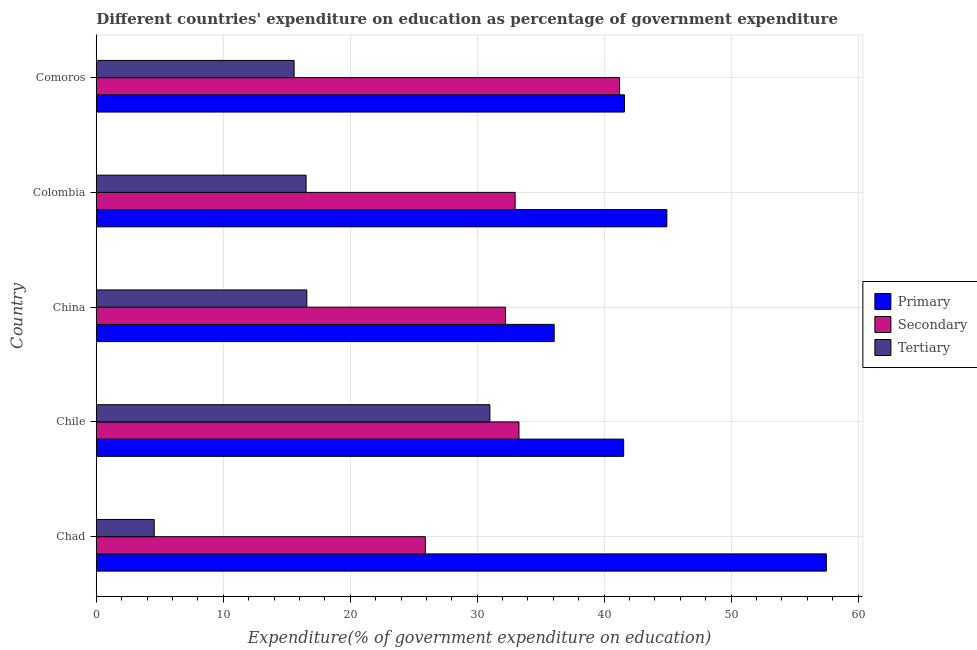How many bars are there on the 3rd tick from the top?
Your answer should be compact. 3. How many bars are there on the 4th tick from the bottom?
Offer a terse response. 3. What is the label of the 2nd group of bars from the top?
Your answer should be compact. Colombia. In how many cases, is the number of bars for a given country not equal to the number of legend labels?
Offer a very short reply. 0. What is the expenditure on secondary education in Comoros?
Keep it short and to the point. 41.21. Across all countries, what is the maximum expenditure on tertiary education?
Your response must be concise. 31. Across all countries, what is the minimum expenditure on secondary education?
Offer a terse response. 25.92. In which country was the expenditure on secondary education maximum?
Provide a succinct answer. Comoros. In which country was the expenditure on tertiary education minimum?
Provide a short and direct response. Chad. What is the total expenditure on tertiary education in the graph?
Your answer should be very brief. 84.25. What is the difference between the expenditure on secondary education in China and that in Comoros?
Provide a short and direct response. -8.98. What is the difference between the expenditure on secondary education in China and the expenditure on tertiary education in Chad?
Make the answer very short. 27.66. What is the average expenditure on primary education per country?
Provide a succinct answer. 44.33. What is the difference between the expenditure on secondary education and expenditure on tertiary education in Comoros?
Provide a short and direct response. 25.63. What is the ratio of the expenditure on primary education in China to that in Colombia?
Offer a terse response. 0.8. Is the difference between the expenditure on tertiary education in Chile and Comoros greater than the difference between the expenditure on primary education in Chile and Comoros?
Offer a very short reply. Yes. What is the difference between the highest and the second highest expenditure on primary education?
Give a very brief answer. 12.56. What is the difference between the highest and the lowest expenditure on primary education?
Make the answer very short. 21.44. Is the sum of the expenditure on tertiary education in China and Colombia greater than the maximum expenditure on primary education across all countries?
Your response must be concise. No. What does the 2nd bar from the top in Comoros represents?
Give a very brief answer. Secondary. What does the 1st bar from the bottom in Chile represents?
Your response must be concise. Primary. Is it the case that in every country, the sum of the expenditure on primary education and expenditure on secondary education is greater than the expenditure on tertiary education?
Keep it short and to the point. Yes. How many bars are there?
Your response must be concise. 15. Are all the bars in the graph horizontal?
Offer a very short reply. Yes. How many countries are there in the graph?
Give a very brief answer. 5. What is the difference between two consecutive major ticks on the X-axis?
Offer a terse response. 10. Are the values on the major ticks of X-axis written in scientific E-notation?
Make the answer very short. No. Where does the legend appear in the graph?
Your response must be concise. Center right. How many legend labels are there?
Make the answer very short. 3. How are the legend labels stacked?
Keep it short and to the point. Vertical. What is the title of the graph?
Give a very brief answer. Different countries' expenditure on education as percentage of government expenditure. What is the label or title of the X-axis?
Provide a succinct answer. Expenditure(% of government expenditure on education). What is the Expenditure(% of government expenditure on education) in Primary in Chad?
Keep it short and to the point. 57.5. What is the Expenditure(% of government expenditure on education) of Secondary in Chad?
Give a very brief answer. 25.92. What is the Expenditure(% of government expenditure on education) of Tertiary in Chad?
Ensure brevity in your answer.  4.57. What is the Expenditure(% of government expenditure on education) of Primary in Chile?
Keep it short and to the point. 41.54. What is the Expenditure(% of government expenditure on education) of Secondary in Chile?
Provide a short and direct response. 33.29. What is the Expenditure(% of government expenditure on education) in Tertiary in Chile?
Offer a terse response. 31. What is the Expenditure(% of government expenditure on education) in Primary in China?
Ensure brevity in your answer.  36.06. What is the Expenditure(% of government expenditure on education) in Secondary in China?
Ensure brevity in your answer.  32.23. What is the Expenditure(% of government expenditure on education) of Tertiary in China?
Keep it short and to the point. 16.58. What is the Expenditure(% of government expenditure on education) in Primary in Colombia?
Your answer should be very brief. 44.94. What is the Expenditure(% of government expenditure on education) of Secondary in Colombia?
Your answer should be compact. 32.99. What is the Expenditure(% of government expenditure on education) in Tertiary in Colombia?
Offer a terse response. 16.52. What is the Expenditure(% of government expenditure on education) in Primary in Comoros?
Make the answer very short. 41.6. What is the Expenditure(% of government expenditure on education) of Secondary in Comoros?
Your answer should be very brief. 41.21. What is the Expenditure(% of government expenditure on education) of Tertiary in Comoros?
Provide a succinct answer. 15.58. Across all countries, what is the maximum Expenditure(% of government expenditure on education) in Primary?
Make the answer very short. 57.5. Across all countries, what is the maximum Expenditure(% of government expenditure on education) of Secondary?
Provide a short and direct response. 41.21. Across all countries, what is the maximum Expenditure(% of government expenditure on education) of Tertiary?
Your answer should be compact. 31. Across all countries, what is the minimum Expenditure(% of government expenditure on education) of Primary?
Offer a very short reply. 36.06. Across all countries, what is the minimum Expenditure(% of government expenditure on education) in Secondary?
Make the answer very short. 25.92. Across all countries, what is the minimum Expenditure(% of government expenditure on education) of Tertiary?
Your response must be concise. 4.57. What is the total Expenditure(% of government expenditure on education) in Primary in the graph?
Ensure brevity in your answer.  221.64. What is the total Expenditure(% of government expenditure on education) in Secondary in the graph?
Offer a terse response. 165.64. What is the total Expenditure(% of government expenditure on education) in Tertiary in the graph?
Your response must be concise. 84.25. What is the difference between the Expenditure(% of government expenditure on education) in Primary in Chad and that in Chile?
Your answer should be compact. 15.96. What is the difference between the Expenditure(% of government expenditure on education) of Secondary in Chad and that in Chile?
Make the answer very short. -7.37. What is the difference between the Expenditure(% of government expenditure on education) in Tertiary in Chad and that in Chile?
Give a very brief answer. -26.43. What is the difference between the Expenditure(% of government expenditure on education) of Primary in Chad and that in China?
Make the answer very short. 21.44. What is the difference between the Expenditure(% of government expenditure on education) of Secondary in Chad and that in China?
Provide a succinct answer. -6.31. What is the difference between the Expenditure(% of government expenditure on education) in Tertiary in Chad and that in China?
Your answer should be very brief. -12.02. What is the difference between the Expenditure(% of government expenditure on education) of Primary in Chad and that in Colombia?
Your answer should be compact. 12.56. What is the difference between the Expenditure(% of government expenditure on education) of Secondary in Chad and that in Colombia?
Make the answer very short. -7.07. What is the difference between the Expenditure(% of government expenditure on education) of Tertiary in Chad and that in Colombia?
Your response must be concise. -11.96. What is the difference between the Expenditure(% of government expenditure on education) in Primary in Chad and that in Comoros?
Ensure brevity in your answer.  15.9. What is the difference between the Expenditure(% of government expenditure on education) in Secondary in Chad and that in Comoros?
Give a very brief answer. -15.29. What is the difference between the Expenditure(% of government expenditure on education) in Tertiary in Chad and that in Comoros?
Provide a short and direct response. -11.02. What is the difference between the Expenditure(% of government expenditure on education) in Primary in Chile and that in China?
Provide a succinct answer. 5.47. What is the difference between the Expenditure(% of government expenditure on education) in Secondary in Chile and that in China?
Give a very brief answer. 1.06. What is the difference between the Expenditure(% of government expenditure on education) of Tertiary in Chile and that in China?
Your answer should be compact. 14.42. What is the difference between the Expenditure(% of government expenditure on education) in Primary in Chile and that in Colombia?
Ensure brevity in your answer.  -3.4. What is the difference between the Expenditure(% of government expenditure on education) of Secondary in Chile and that in Colombia?
Make the answer very short. 0.3. What is the difference between the Expenditure(% of government expenditure on education) of Tertiary in Chile and that in Colombia?
Provide a succinct answer. 14.48. What is the difference between the Expenditure(% of government expenditure on education) of Primary in Chile and that in Comoros?
Ensure brevity in your answer.  -0.06. What is the difference between the Expenditure(% of government expenditure on education) in Secondary in Chile and that in Comoros?
Provide a short and direct response. -7.92. What is the difference between the Expenditure(% of government expenditure on education) of Tertiary in Chile and that in Comoros?
Keep it short and to the point. 15.42. What is the difference between the Expenditure(% of government expenditure on education) in Primary in China and that in Colombia?
Your answer should be compact. -8.87. What is the difference between the Expenditure(% of government expenditure on education) in Secondary in China and that in Colombia?
Keep it short and to the point. -0.76. What is the difference between the Expenditure(% of government expenditure on education) of Tertiary in China and that in Colombia?
Offer a very short reply. 0.06. What is the difference between the Expenditure(% of government expenditure on education) of Primary in China and that in Comoros?
Provide a succinct answer. -5.54. What is the difference between the Expenditure(% of government expenditure on education) of Secondary in China and that in Comoros?
Your answer should be compact. -8.98. What is the difference between the Expenditure(% of government expenditure on education) of Primary in Colombia and that in Comoros?
Provide a short and direct response. 3.34. What is the difference between the Expenditure(% of government expenditure on education) in Secondary in Colombia and that in Comoros?
Keep it short and to the point. -8.22. What is the difference between the Expenditure(% of government expenditure on education) of Tertiary in Colombia and that in Comoros?
Your response must be concise. 0.94. What is the difference between the Expenditure(% of government expenditure on education) of Primary in Chad and the Expenditure(% of government expenditure on education) of Secondary in Chile?
Your answer should be compact. 24.21. What is the difference between the Expenditure(% of government expenditure on education) in Primary in Chad and the Expenditure(% of government expenditure on education) in Tertiary in Chile?
Your answer should be very brief. 26.5. What is the difference between the Expenditure(% of government expenditure on education) in Secondary in Chad and the Expenditure(% of government expenditure on education) in Tertiary in Chile?
Your response must be concise. -5.08. What is the difference between the Expenditure(% of government expenditure on education) of Primary in Chad and the Expenditure(% of government expenditure on education) of Secondary in China?
Make the answer very short. 25.27. What is the difference between the Expenditure(% of government expenditure on education) of Primary in Chad and the Expenditure(% of government expenditure on education) of Tertiary in China?
Make the answer very short. 40.92. What is the difference between the Expenditure(% of government expenditure on education) in Secondary in Chad and the Expenditure(% of government expenditure on education) in Tertiary in China?
Your answer should be compact. 9.34. What is the difference between the Expenditure(% of government expenditure on education) of Primary in Chad and the Expenditure(% of government expenditure on education) of Secondary in Colombia?
Make the answer very short. 24.51. What is the difference between the Expenditure(% of government expenditure on education) of Primary in Chad and the Expenditure(% of government expenditure on education) of Tertiary in Colombia?
Your response must be concise. 40.98. What is the difference between the Expenditure(% of government expenditure on education) of Secondary in Chad and the Expenditure(% of government expenditure on education) of Tertiary in Colombia?
Offer a very short reply. 9.39. What is the difference between the Expenditure(% of government expenditure on education) of Primary in Chad and the Expenditure(% of government expenditure on education) of Secondary in Comoros?
Keep it short and to the point. 16.29. What is the difference between the Expenditure(% of government expenditure on education) in Primary in Chad and the Expenditure(% of government expenditure on education) in Tertiary in Comoros?
Provide a short and direct response. 41.92. What is the difference between the Expenditure(% of government expenditure on education) of Secondary in Chad and the Expenditure(% of government expenditure on education) of Tertiary in Comoros?
Give a very brief answer. 10.34. What is the difference between the Expenditure(% of government expenditure on education) in Primary in Chile and the Expenditure(% of government expenditure on education) in Secondary in China?
Your answer should be very brief. 9.31. What is the difference between the Expenditure(% of government expenditure on education) in Primary in Chile and the Expenditure(% of government expenditure on education) in Tertiary in China?
Make the answer very short. 24.95. What is the difference between the Expenditure(% of government expenditure on education) of Secondary in Chile and the Expenditure(% of government expenditure on education) of Tertiary in China?
Offer a terse response. 16.71. What is the difference between the Expenditure(% of government expenditure on education) in Primary in Chile and the Expenditure(% of government expenditure on education) in Secondary in Colombia?
Keep it short and to the point. 8.55. What is the difference between the Expenditure(% of government expenditure on education) of Primary in Chile and the Expenditure(% of government expenditure on education) of Tertiary in Colombia?
Make the answer very short. 25.01. What is the difference between the Expenditure(% of government expenditure on education) of Secondary in Chile and the Expenditure(% of government expenditure on education) of Tertiary in Colombia?
Give a very brief answer. 16.77. What is the difference between the Expenditure(% of government expenditure on education) in Primary in Chile and the Expenditure(% of government expenditure on education) in Secondary in Comoros?
Provide a short and direct response. 0.32. What is the difference between the Expenditure(% of government expenditure on education) of Primary in Chile and the Expenditure(% of government expenditure on education) of Tertiary in Comoros?
Provide a succinct answer. 25.95. What is the difference between the Expenditure(% of government expenditure on education) of Secondary in Chile and the Expenditure(% of government expenditure on education) of Tertiary in Comoros?
Give a very brief answer. 17.71. What is the difference between the Expenditure(% of government expenditure on education) of Primary in China and the Expenditure(% of government expenditure on education) of Secondary in Colombia?
Provide a short and direct response. 3.07. What is the difference between the Expenditure(% of government expenditure on education) in Primary in China and the Expenditure(% of government expenditure on education) in Tertiary in Colombia?
Provide a succinct answer. 19.54. What is the difference between the Expenditure(% of government expenditure on education) in Secondary in China and the Expenditure(% of government expenditure on education) in Tertiary in Colombia?
Ensure brevity in your answer.  15.71. What is the difference between the Expenditure(% of government expenditure on education) in Primary in China and the Expenditure(% of government expenditure on education) in Secondary in Comoros?
Ensure brevity in your answer.  -5.15. What is the difference between the Expenditure(% of government expenditure on education) in Primary in China and the Expenditure(% of government expenditure on education) in Tertiary in Comoros?
Your response must be concise. 20.48. What is the difference between the Expenditure(% of government expenditure on education) of Secondary in China and the Expenditure(% of government expenditure on education) of Tertiary in Comoros?
Offer a terse response. 16.65. What is the difference between the Expenditure(% of government expenditure on education) of Primary in Colombia and the Expenditure(% of government expenditure on education) of Secondary in Comoros?
Make the answer very short. 3.73. What is the difference between the Expenditure(% of government expenditure on education) of Primary in Colombia and the Expenditure(% of government expenditure on education) of Tertiary in Comoros?
Your answer should be compact. 29.36. What is the difference between the Expenditure(% of government expenditure on education) of Secondary in Colombia and the Expenditure(% of government expenditure on education) of Tertiary in Comoros?
Your answer should be very brief. 17.41. What is the average Expenditure(% of government expenditure on education) of Primary per country?
Offer a terse response. 44.33. What is the average Expenditure(% of government expenditure on education) in Secondary per country?
Make the answer very short. 33.13. What is the average Expenditure(% of government expenditure on education) in Tertiary per country?
Offer a terse response. 16.85. What is the difference between the Expenditure(% of government expenditure on education) in Primary and Expenditure(% of government expenditure on education) in Secondary in Chad?
Give a very brief answer. 31.58. What is the difference between the Expenditure(% of government expenditure on education) of Primary and Expenditure(% of government expenditure on education) of Tertiary in Chad?
Keep it short and to the point. 52.93. What is the difference between the Expenditure(% of government expenditure on education) of Secondary and Expenditure(% of government expenditure on education) of Tertiary in Chad?
Offer a very short reply. 21.35. What is the difference between the Expenditure(% of government expenditure on education) in Primary and Expenditure(% of government expenditure on education) in Secondary in Chile?
Provide a short and direct response. 8.24. What is the difference between the Expenditure(% of government expenditure on education) in Primary and Expenditure(% of government expenditure on education) in Tertiary in Chile?
Your answer should be very brief. 10.53. What is the difference between the Expenditure(% of government expenditure on education) of Secondary and Expenditure(% of government expenditure on education) of Tertiary in Chile?
Your answer should be compact. 2.29. What is the difference between the Expenditure(% of government expenditure on education) of Primary and Expenditure(% of government expenditure on education) of Secondary in China?
Offer a terse response. 3.83. What is the difference between the Expenditure(% of government expenditure on education) in Primary and Expenditure(% of government expenditure on education) in Tertiary in China?
Provide a succinct answer. 19.48. What is the difference between the Expenditure(% of government expenditure on education) of Secondary and Expenditure(% of government expenditure on education) of Tertiary in China?
Provide a succinct answer. 15.65. What is the difference between the Expenditure(% of government expenditure on education) of Primary and Expenditure(% of government expenditure on education) of Secondary in Colombia?
Keep it short and to the point. 11.95. What is the difference between the Expenditure(% of government expenditure on education) of Primary and Expenditure(% of government expenditure on education) of Tertiary in Colombia?
Make the answer very short. 28.41. What is the difference between the Expenditure(% of government expenditure on education) in Secondary and Expenditure(% of government expenditure on education) in Tertiary in Colombia?
Ensure brevity in your answer.  16.46. What is the difference between the Expenditure(% of government expenditure on education) in Primary and Expenditure(% of government expenditure on education) in Secondary in Comoros?
Offer a terse response. 0.39. What is the difference between the Expenditure(% of government expenditure on education) of Primary and Expenditure(% of government expenditure on education) of Tertiary in Comoros?
Offer a terse response. 26.02. What is the difference between the Expenditure(% of government expenditure on education) in Secondary and Expenditure(% of government expenditure on education) in Tertiary in Comoros?
Give a very brief answer. 25.63. What is the ratio of the Expenditure(% of government expenditure on education) in Primary in Chad to that in Chile?
Your response must be concise. 1.38. What is the ratio of the Expenditure(% of government expenditure on education) of Secondary in Chad to that in Chile?
Ensure brevity in your answer.  0.78. What is the ratio of the Expenditure(% of government expenditure on education) in Tertiary in Chad to that in Chile?
Give a very brief answer. 0.15. What is the ratio of the Expenditure(% of government expenditure on education) in Primary in Chad to that in China?
Provide a short and direct response. 1.59. What is the ratio of the Expenditure(% of government expenditure on education) of Secondary in Chad to that in China?
Provide a succinct answer. 0.8. What is the ratio of the Expenditure(% of government expenditure on education) of Tertiary in Chad to that in China?
Give a very brief answer. 0.28. What is the ratio of the Expenditure(% of government expenditure on education) in Primary in Chad to that in Colombia?
Offer a very short reply. 1.28. What is the ratio of the Expenditure(% of government expenditure on education) in Secondary in Chad to that in Colombia?
Your answer should be very brief. 0.79. What is the ratio of the Expenditure(% of government expenditure on education) of Tertiary in Chad to that in Colombia?
Your answer should be compact. 0.28. What is the ratio of the Expenditure(% of government expenditure on education) of Primary in Chad to that in Comoros?
Provide a succinct answer. 1.38. What is the ratio of the Expenditure(% of government expenditure on education) in Secondary in Chad to that in Comoros?
Provide a succinct answer. 0.63. What is the ratio of the Expenditure(% of government expenditure on education) in Tertiary in Chad to that in Comoros?
Ensure brevity in your answer.  0.29. What is the ratio of the Expenditure(% of government expenditure on education) of Primary in Chile to that in China?
Offer a terse response. 1.15. What is the ratio of the Expenditure(% of government expenditure on education) in Secondary in Chile to that in China?
Your answer should be compact. 1.03. What is the ratio of the Expenditure(% of government expenditure on education) in Tertiary in Chile to that in China?
Your answer should be very brief. 1.87. What is the ratio of the Expenditure(% of government expenditure on education) of Primary in Chile to that in Colombia?
Your answer should be compact. 0.92. What is the ratio of the Expenditure(% of government expenditure on education) of Secondary in Chile to that in Colombia?
Provide a succinct answer. 1.01. What is the ratio of the Expenditure(% of government expenditure on education) of Tertiary in Chile to that in Colombia?
Provide a succinct answer. 1.88. What is the ratio of the Expenditure(% of government expenditure on education) in Primary in Chile to that in Comoros?
Provide a short and direct response. 1. What is the ratio of the Expenditure(% of government expenditure on education) of Secondary in Chile to that in Comoros?
Your answer should be compact. 0.81. What is the ratio of the Expenditure(% of government expenditure on education) in Tertiary in Chile to that in Comoros?
Give a very brief answer. 1.99. What is the ratio of the Expenditure(% of government expenditure on education) of Primary in China to that in Colombia?
Ensure brevity in your answer.  0.8. What is the ratio of the Expenditure(% of government expenditure on education) in Secondary in China to that in Colombia?
Your response must be concise. 0.98. What is the ratio of the Expenditure(% of government expenditure on education) of Tertiary in China to that in Colombia?
Offer a very short reply. 1. What is the ratio of the Expenditure(% of government expenditure on education) in Primary in China to that in Comoros?
Your response must be concise. 0.87. What is the ratio of the Expenditure(% of government expenditure on education) in Secondary in China to that in Comoros?
Give a very brief answer. 0.78. What is the ratio of the Expenditure(% of government expenditure on education) in Tertiary in China to that in Comoros?
Offer a very short reply. 1.06. What is the ratio of the Expenditure(% of government expenditure on education) in Primary in Colombia to that in Comoros?
Your answer should be very brief. 1.08. What is the ratio of the Expenditure(% of government expenditure on education) of Secondary in Colombia to that in Comoros?
Keep it short and to the point. 0.8. What is the ratio of the Expenditure(% of government expenditure on education) of Tertiary in Colombia to that in Comoros?
Keep it short and to the point. 1.06. What is the difference between the highest and the second highest Expenditure(% of government expenditure on education) of Primary?
Offer a very short reply. 12.56. What is the difference between the highest and the second highest Expenditure(% of government expenditure on education) of Secondary?
Your response must be concise. 7.92. What is the difference between the highest and the second highest Expenditure(% of government expenditure on education) of Tertiary?
Make the answer very short. 14.42. What is the difference between the highest and the lowest Expenditure(% of government expenditure on education) in Primary?
Your answer should be compact. 21.44. What is the difference between the highest and the lowest Expenditure(% of government expenditure on education) in Secondary?
Ensure brevity in your answer.  15.29. What is the difference between the highest and the lowest Expenditure(% of government expenditure on education) in Tertiary?
Provide a succinct answer. 26.43. 